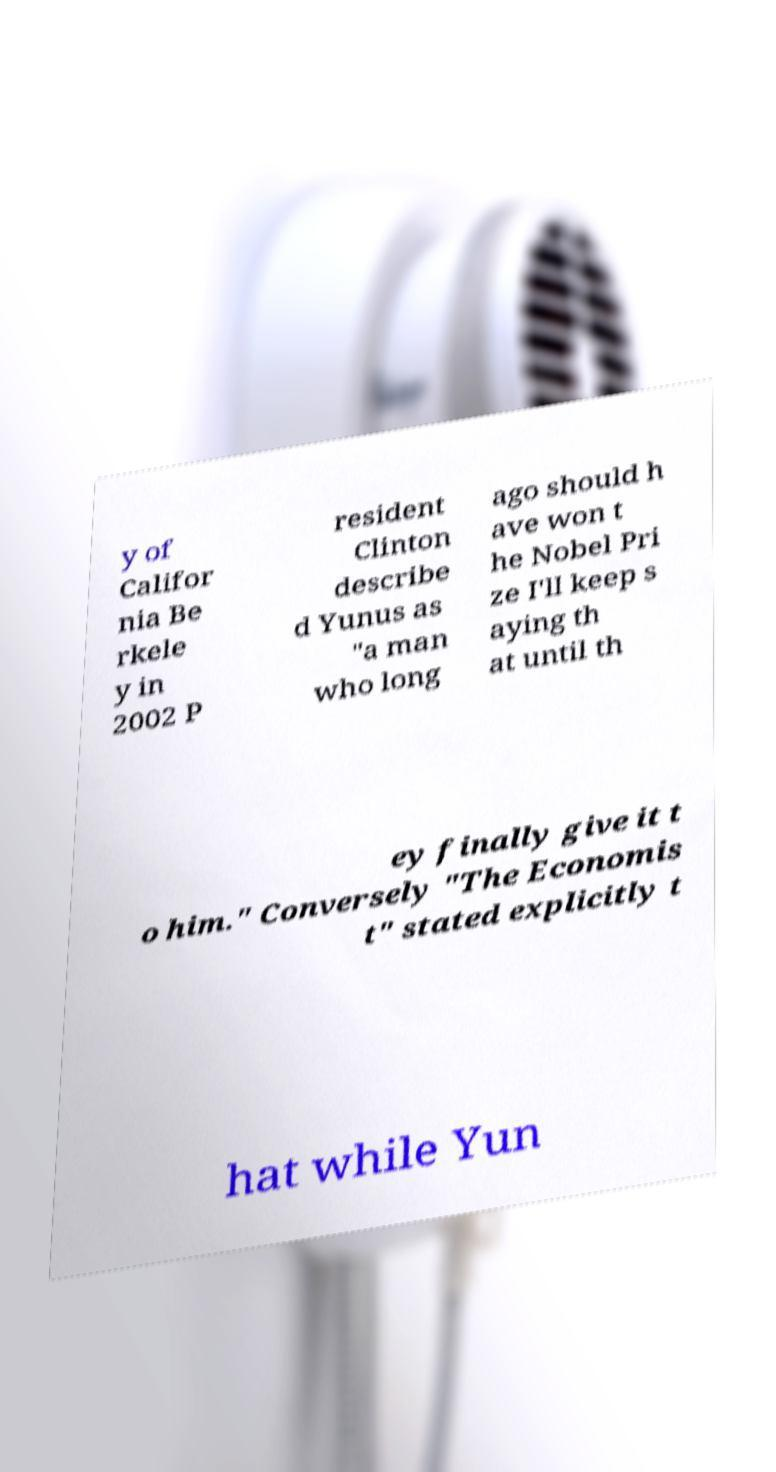I need the written content from this picture converted into text. Can you do that? y of Califor nia Be rkele y in 2002 P resident Clinton describe d Yunus as "a man who long ago should h ave won t he Nobel Pri ze I'll keep s aying th at until th ey finally give it t o him." Conversely "The Economis t" stated explicitly t hat while Yun 